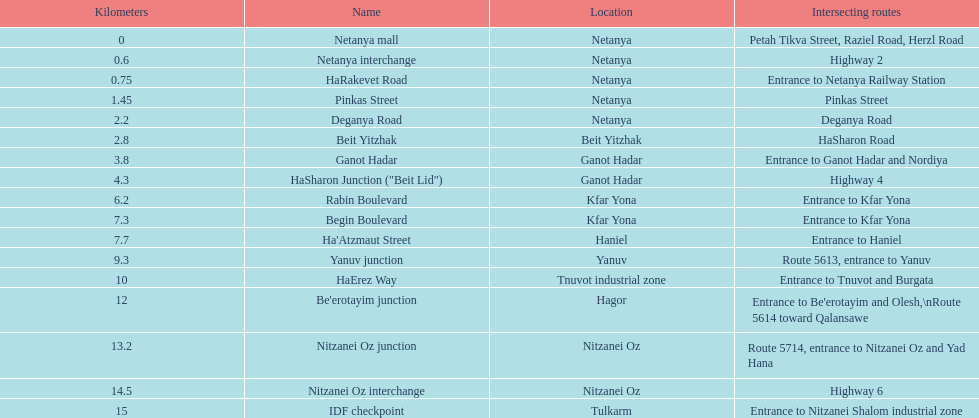Which area can be found subsequent to kfar yona? Haniel. 